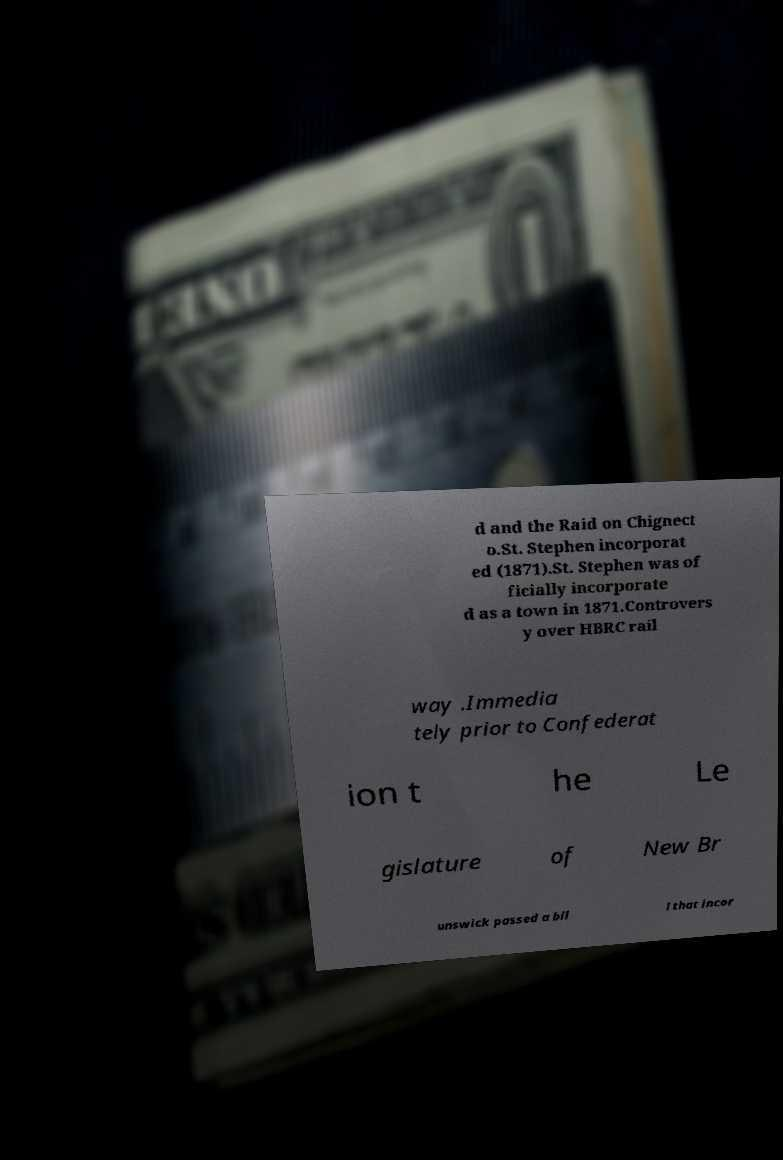For documentation purposes, I need the text within this image transcribed. Could you provide that? d and the Raid on Chignect o.St. Stephen incorporat ed (1871).St. Stephen was of ficially incorporate d as a town in 1871.Controvers y over HBRC rail way .Immedia tely prior to Confederat ion t he Le gislature of New Br unswick passed a bil l that incor 